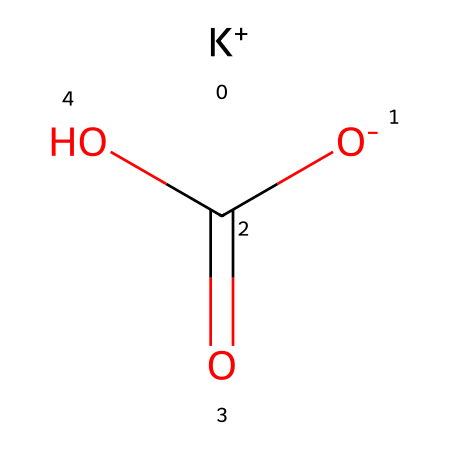What is the name of this chemical? The SMILES representation indicates the presence of potassium (K), hydrogen (H), carbon (C), and oxygen (O), which together form potassium bicarbonate.
Answer: potassium bicarbonate How many oxygen atoms are present in this chemical? By examining the structure, we see that there are three oxygen atoms connected to one carbon atom in the bicarbonate group.
Answer: three What is the charge of potassium in this chemical? In the given structure, potassium (K) is represented as K+, indicating it has a positive charge of +1.
Answer: +1 Is potassium bicarbonate a strong or weak base? Since potassium bicarbonate partially dissociates in water and does not fully ionize, it is classified as a weak base.
Answer: weak What elements are present in potassium bicarbonate? The structure contains potassium (K), carbon (C), hydrogen (H), and oxygen (O) as its constituent elements.
Answer: potassium, carbon, hydrogen, oxygen Which part of the chemical contributes to its use in baking? The bicarbonate ion (HCO3-) is responsible for the leavening action when it reacts with acids during baking, producing carbon dioxide.
Answer: bicarbonate ion 